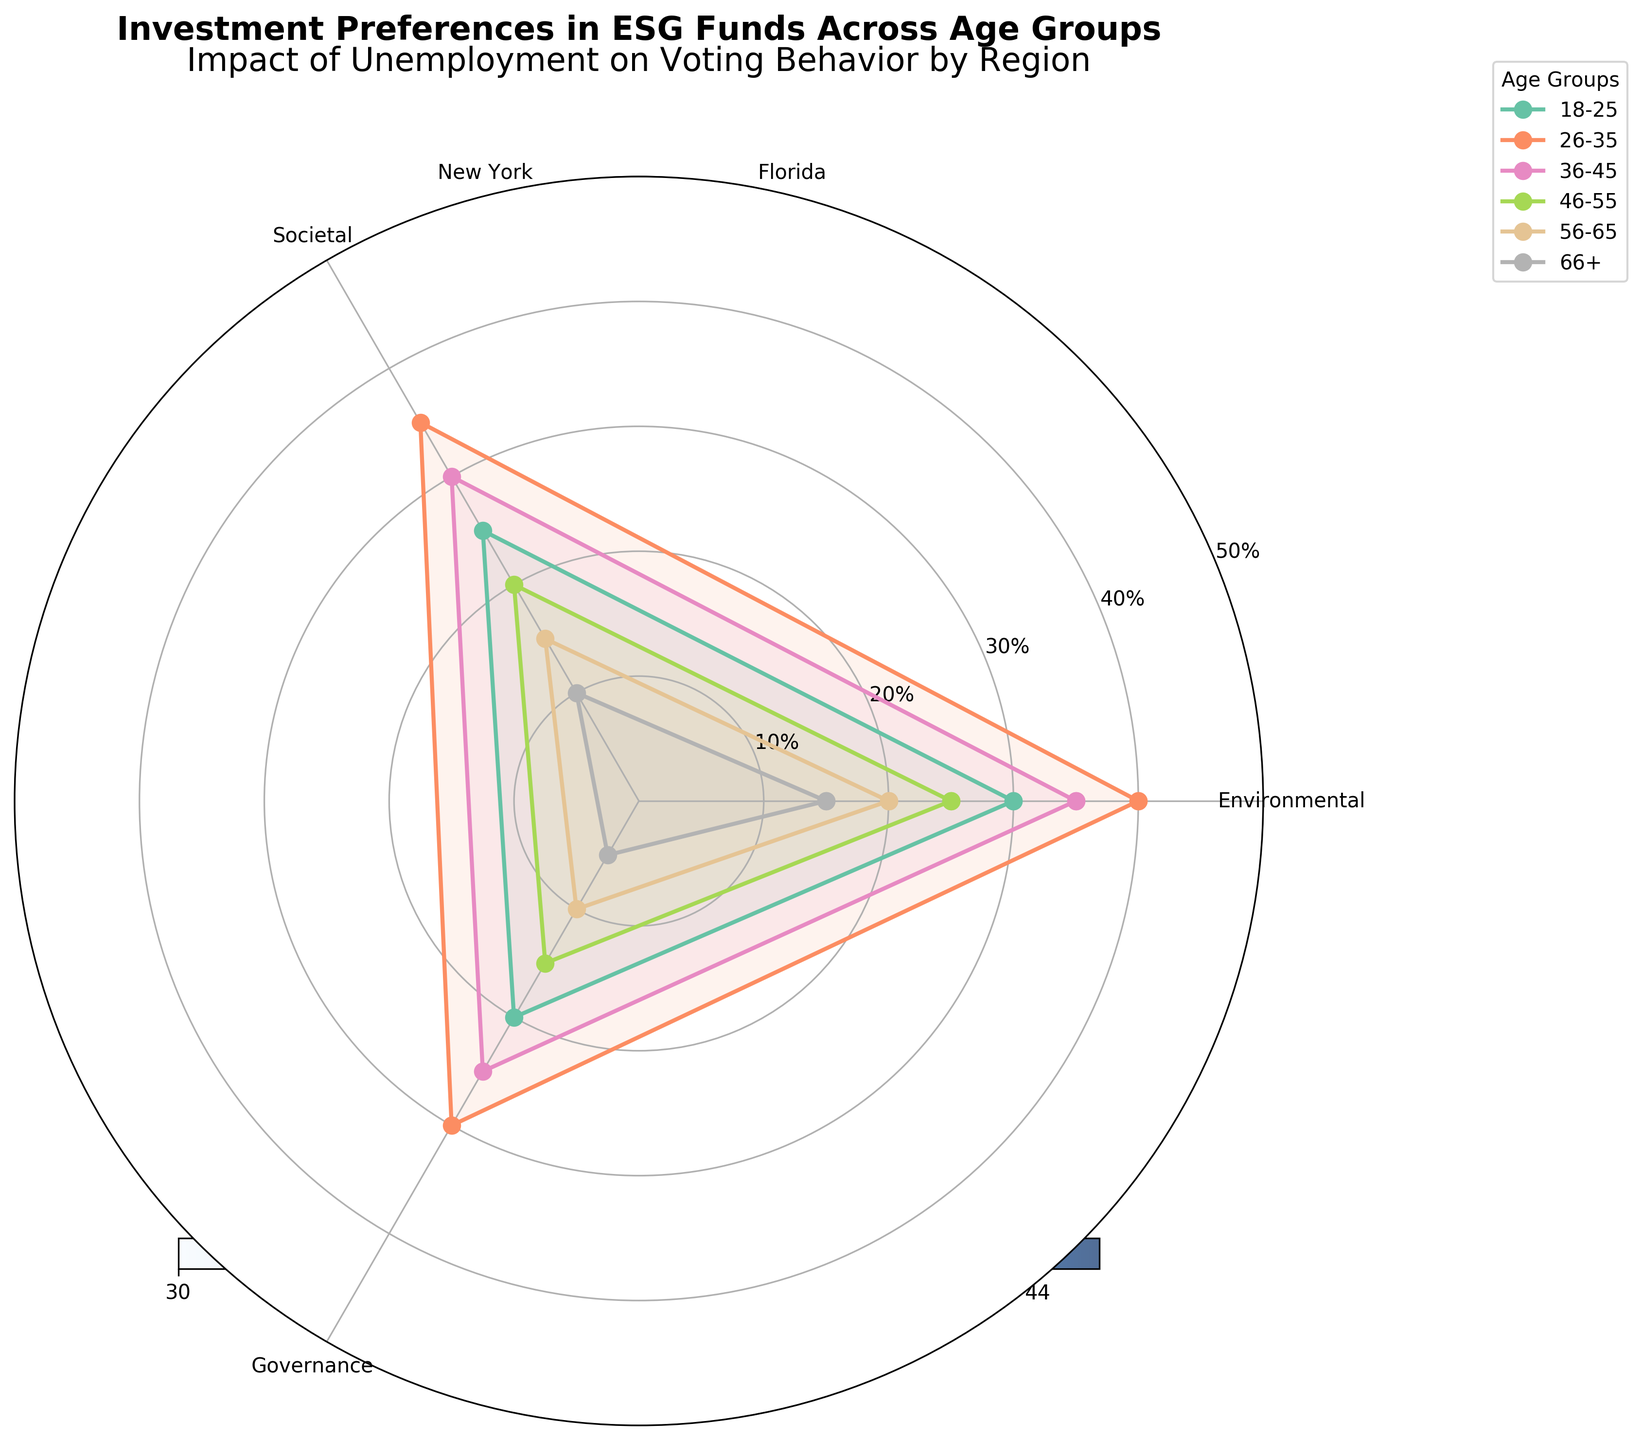What age group has the highest preference for Environmental investment? The line for the age group 26-35 shows the highest point on the Environmental axis, which is 40%.
Answer: 26-35 What is the title of the chart? The title is written at the top of the chart.
Answer: Investment Preferences in ESG Funds Across Age Groups How do the preferences for Governance investments compare between the youngest (18-25) and oldest (66+) age groups? The preference for Governance investment in the 18-25 age group is 20%, while in the 66+ age group, it is 5%.
Answer: The youngest group (18-25) has a 15% higher preference for Governance investments than the oldest group (66+) Which age group shows the least interest in Societal investment? The line for the age group 66+ is the lowest on the Societal axis, displaying 10%.
Answer: 66+ What is the range of Environmental investment preferences across all age groups? The highest preference is 40% (age group 26-35), and the lowest is 15% (age group 66+).
Answer: The range is 25% How does the preference for Societal investments in the 26-35 age group compare to the 36-45 age group? The preference for Societal investment in the 26-35 group is 35%, while for the 36-45 group, it is 30%.
Answer: The 26-35 age group has a 5% higher preference for Societal investments compared to the 36-45 age group What category has the lowest investment preference in the age group 46-55? In the 46-55 age group, the lowest point is on the Governance axis at 15%.
Answer: Governance Which age group has the highest combined preference for Environmental and Societal investments? Adding the percentages for the Environmental and Societal preferences for each age group shows that the age group 26-35 has the highest total (40% + 35% = 75%).
Answer: 26-35 How do the preferences between Environmental and Governance investments change as age increases? Environmental preference decreases from 30% (18-25) to 15% (66+), and Governance preference decreases from 20% (18-25) to 5% (66+).
Answer: Both Environmental and Governance preferences decrease with age What is the average preference for Governance investments across all age groups? The values for Governance are 20, 30, 25, 15, 10, and 5%. Adding these gives 105, and the average is 105/6 = 17.5%.
Answer: 17.5% 